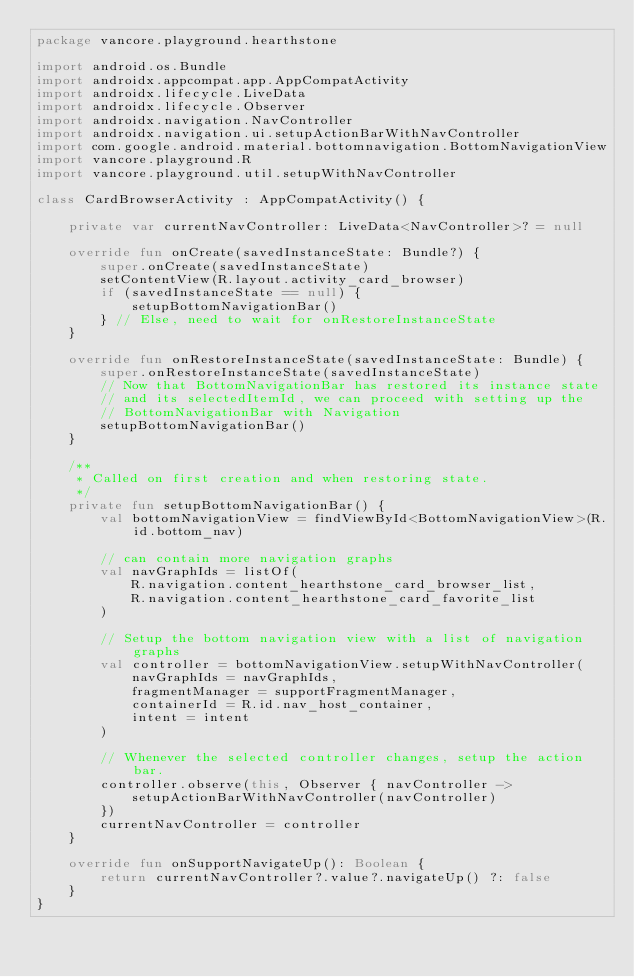<code> <loc_0><loc_0><loc_500><loc_500><_Kotlin_>package vancore.playground.hearthstone

import android.os.Bundle
import androidx.appcompat.app.AppCompatActivity
import androidx.lifecycle.LiveData
import androidx.lifecycle.Observer
import androidx.navigation.NavController
import androidx.navigation.ui.setupActionBarWithNavController
import com.google.android.material.bottomnavigation.BottomNavigationView
import vancore.playground.R
import vancore.playground.util.setupWithNavController

class CardBrowserActivity : AppCompatActivity() {

    private var currentNavController: LiveData<NavController>? = null

    override fun onCreate(savedInstanceState: Bundle?) {
        super.onCreate(savedInstanceState)
        setContentView(R.layout.activity_card_browser)
        if (savedInstanceState == null) {
            setupBottomNavigationBar()
        } // Else, need to wait for onRestoreInstanceState
    }

    override fun onRestoreInstanceState(savedInstanceState: Bundle) {
        super.onRestoreInstanceState(savedInstanceState)
        // Now that BottomNavigationBar has restored its instance state
        // and its selectedItemId, we can proceed with setting up the
        // BottomNavigationBar with Navigation
        setupBottomNavigationBar()
    }

    /**
     * Called on first creation and when restoring state.
     */
    private fun setupBottomNavigationBar() {
        val bottomNavigationView = findViewById<BottomNavigationView>(R.id.bottom_nav)

        // can contain more navigation graphs
        val navGraphIds = listOf(
            R.navigation.content_hearthstone_card_browser_list,
            R.navigation.content_hearthstone_card_favorite_list
        )

        // Setup the bottom navigation view with a list of navigation graphs
        val controller = bottomNavigationView.setupWithNavController(
            navGraphIds = navGraphIds,
            fragmentManager = supportFragmentManager,
            containerId = R.id.nav_host_container,
            intent = intent
        )

        // Whenever the selected controller changes, setup the action bar.
        controller.observe(this, Observer { navController ->
            setupActionBarWithNavController(navController)
        })
        currentNavController = controller
    }

    override fun onSupportNavigateUp(): Boolean {
        return currentNavController?.value?.navigateUp() ?: false
    }
}</code> 